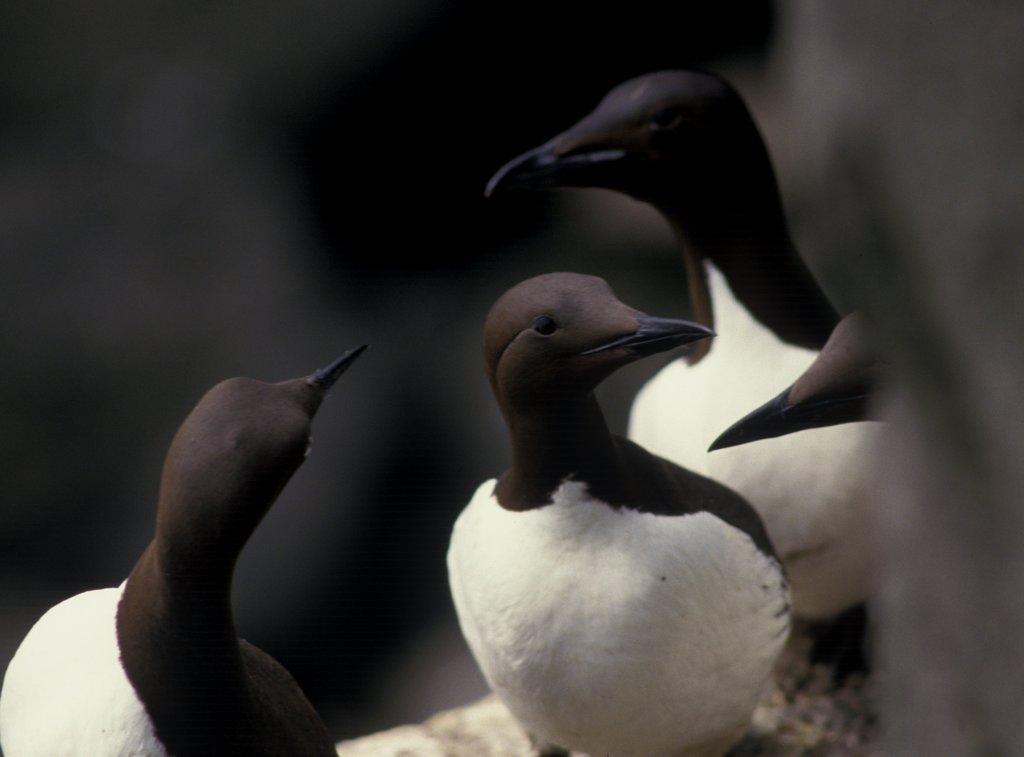How would you summarize this image in a sentence or two? In this picture I can observe birds. They are in black and white color. The background is blurry. 